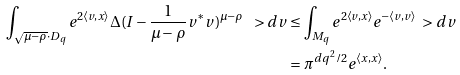<formula> <loc_0><loc_0><loc_500><loc_500>\int _ { \sqrt { \mu - \rho } \cdot D _ { q } } e ^ { 2 \langle v , x \rangle } \Delta ( I - \frac { 1 } { \mu - \rho } v ^ { * } v ) ^ { \mu - \rho } \ > d v & \leq \int _ { M _ { q } } e ^ { 2 \langle v , x \rangle } e ^ { - \langle v , v \rangle } \ > d v \\ & = \pi ^ { d q ^ { 2 } / 2 } e ^ { \langle x , x \rangle } .</formula> 